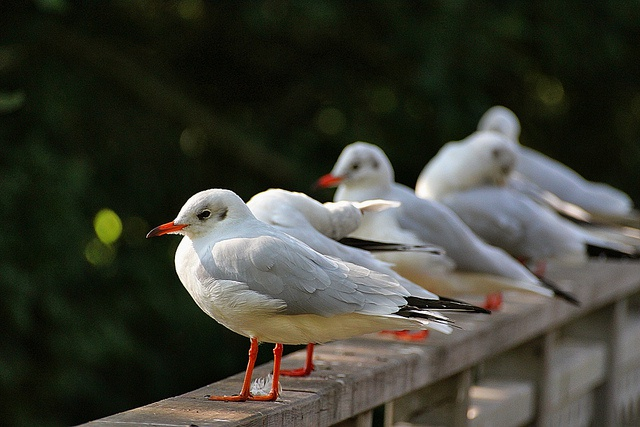Describe the objects in this image and their specific colors. I can see bird in black, darkgray, gray, lightgray, and olive tones, bird in black, darkgray, and gray tones, bird in black, gray, darkgray, and lightgray tones, bird in black, darkgray, and gray tones, and bird in black, darkgray, lightgray, and gray tones in this image. 